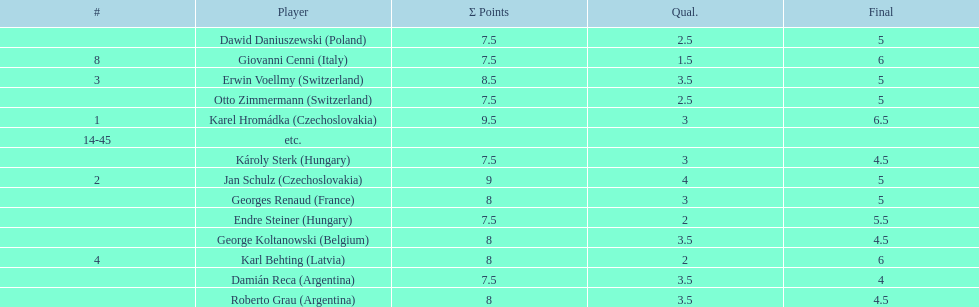Jan schulz is ranked immediately below which player? Karel Hromádka. 